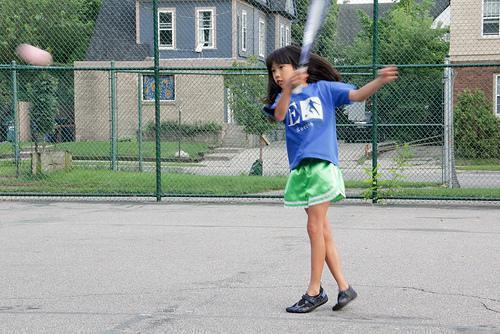How many houses behind the fence are seen?
Give a very brief answer. 3. 